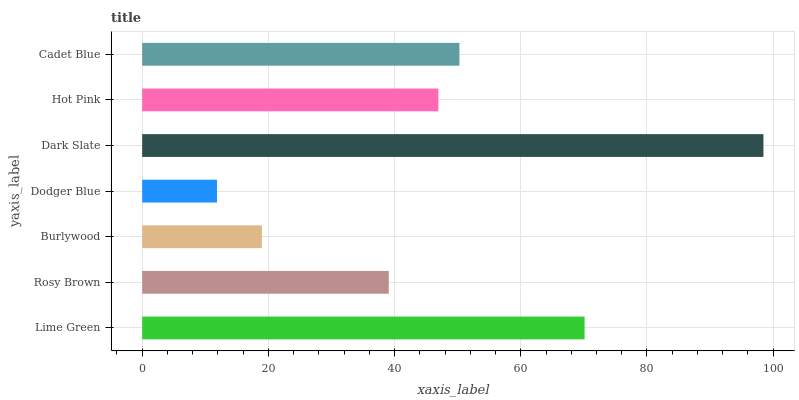Is Dodger Blue the minimum?
Answer yes or no. Yes. Is Dark Slate the maximum?
Answer yes or no. Yes. Is Rosy Brown the minimum?
Answer yes or no. No. Is Rosy Brown the maximum?
Answer yes or no. No. Is Lime Green greater than Rosy Brown?
Answer yes or no. Yes. Is Rosy Brown less than Lime Green?
Answer yes or no. Yes. Is Rosy Brown greater than Lime Green?
Answer yes or no. No. Is Lime Green less than Rosy Brown?
Answer yes or no. No. Is Hot Pink the high median?
Answer yes or no. Yes. Is Hot Pink the low median?
Answer yes or no. Yes. Is Dodger Blue the high median?
Answer yes or no. No. Is Rosy Brown the low median?
Answer yes or no. No. 